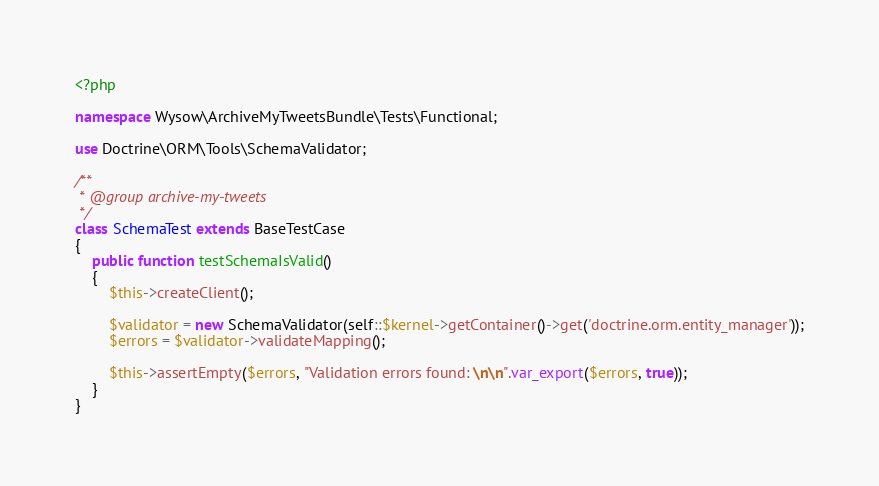<code> <loc_0><loc_0><loc_500><loc_500><_PHP_><?php

namespace Wysow\ArchiveMyTweetsBundle\Tests\Functional;

use Doctrine\ORM\Tools\SchemaValidator;

/**
 * @group archive-my-tweets
 */
class SchemaTest extends BaseTestCase
{
    public function testSchemaIsValid()
    {
        $this->createClient();

        $validator = new SchemaValidator(self::$kernel->getContainer()->get('doctrine.orm.entity_manager'));
        $errors = $validator->validateMapping();

        $this->assertEmpty($errors, "Validation errors found: \n\n".var_export($errors, true));
    }
}</code> 